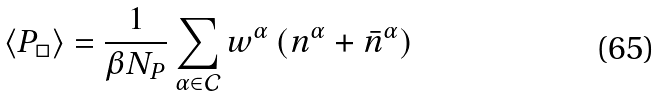Convert formula to latex. <formula><loc_0><loc_0><loc_500><loc_500>\langle P _ { \Box } \rangle = \frac { 1 } { \beta N _ { P } } \sum _ { \alpha \in \mathcal { C } } w ^ { \alpha } \left ( n ^ { \alpha } + \bar { n } ^ { \alpha } \right )</formula> 